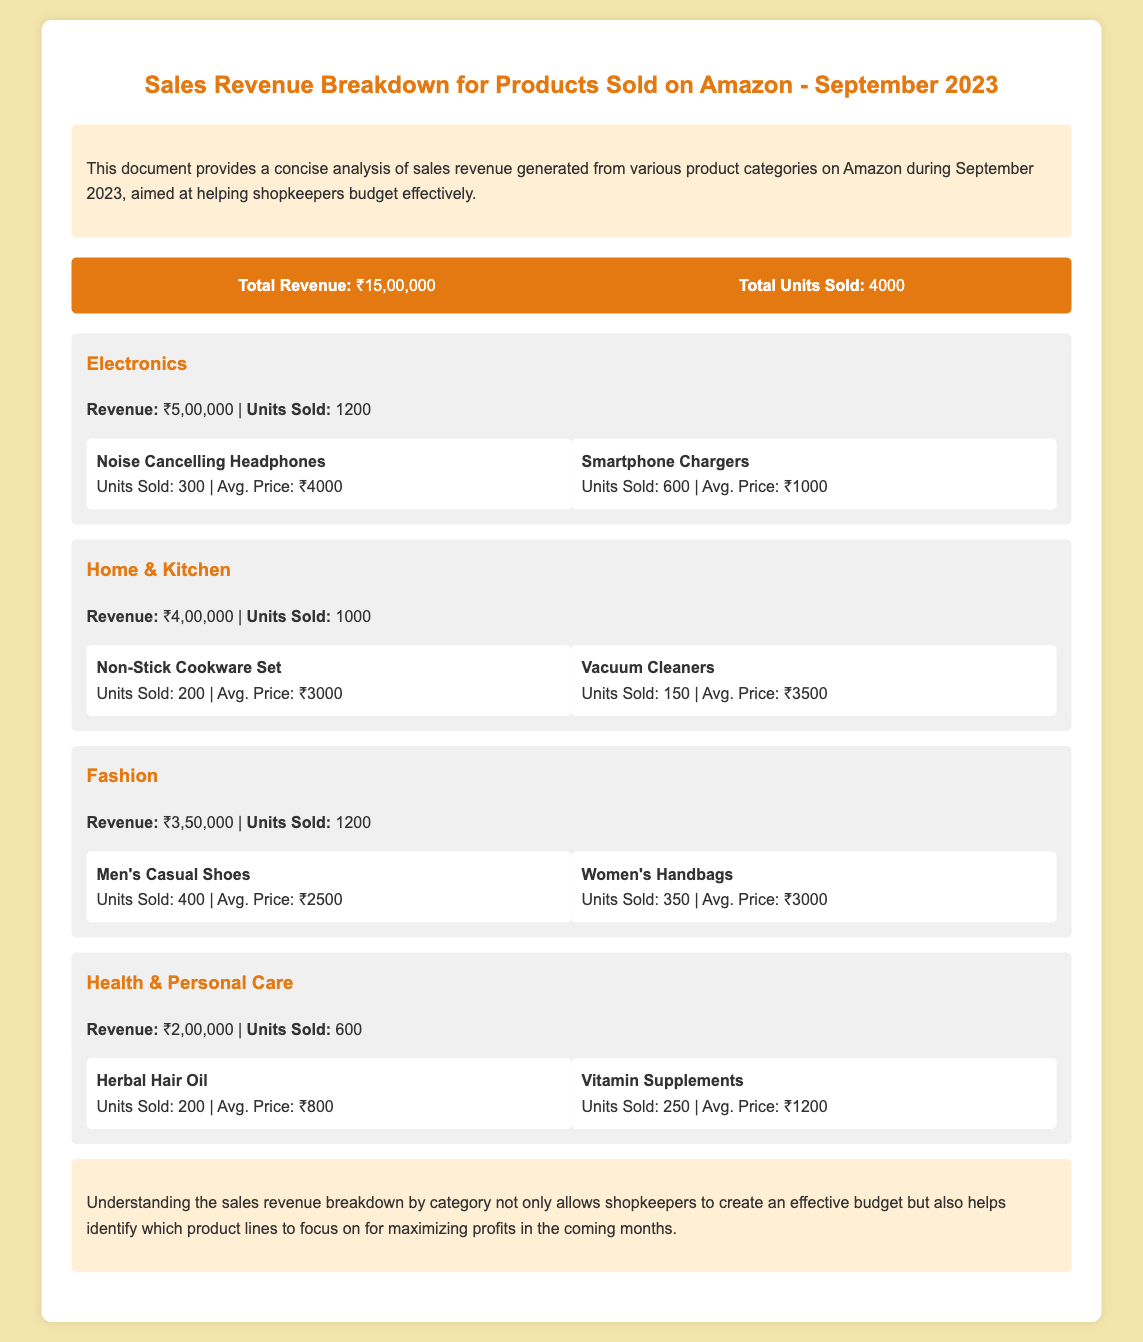What is the total revenue? The total revenue is listed at the top of the document, summarizing the entire sales for September 2023.
Answer: ₹15,00,000 How many units were sold in September 2023? The total units sold are mentioned alongside the total revenue as part of the overall sales summary.
Answer: 4000 What is the revenue for the Electronics category? The revenue breakdown includes a specific figure for the Electronics category.
Answer: ₹5,00,000 Which product in the Fashion category sold the most units? The document lists the top products in the Fashion category, with units sold provided.
Answer: Men's Casual Shoes What is the average price of the Vacuum Cleaners? The average price of the Vacuum Cleaners is provided along with the units sold in the Home & Kitchen category.
Answer: ₹3500 How much revenue did the Health & Personal Care category generate? This information is specified within the category analysis section of the document for Health & Personal Care.
Answer: ₹2,00,000 What is the average price of the Herbal Hair Oil? The average price for the Herbal Hair Oil product is mentioned in the product details under the Health & Personal Care category.
Answer: ₹800 Which category had the highest revenue? The highest revenue can be calculated by comparing the revenue figures provided for each category.
Answer: Electronics What is the total revenue generated from the Fashion category? This revenue figure is directly mentioned within the Fashion category analysis.
Answer: ₹3,50,000 